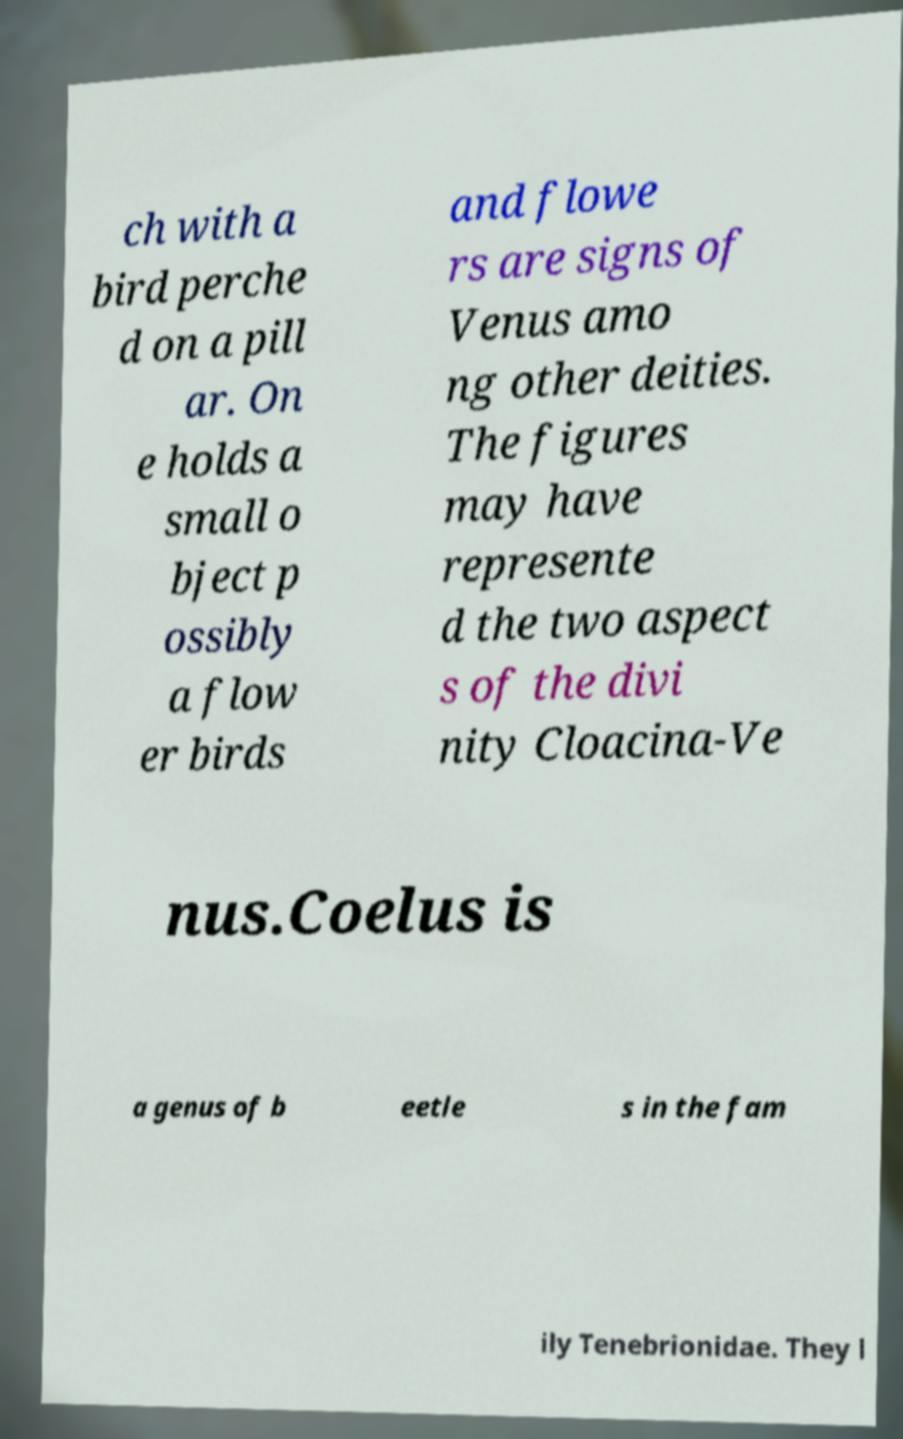Can you accurately transcribe the text from the provided image for me? ch with a bird perche d on a pill ar. On e holds a small o bject p ossibly a flow er birds and flowe rs are signs of Venus amo ng other deities. The figures may have represente d the two aspect s of the divi nity Cloacina-Ve nus.Coelus is a genus of b eetle s in the fam ily Tenebrionidae. They l 